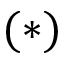<formula> <loc_0><loc_0><loc_500><loc_500>( * )</formula> 